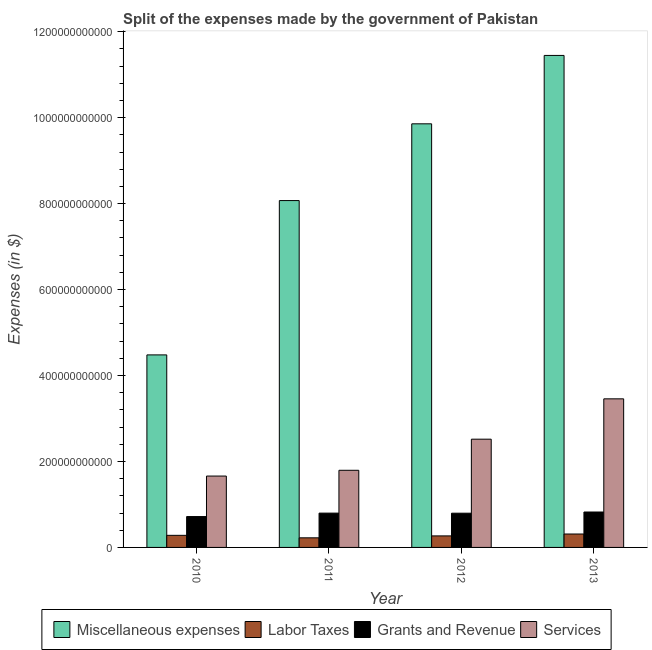How many groups of bars are there?
Give a very brief answer. 4. Are the number of bars per tick equal to the number of legend labels?
Your response must be concise. Yes. How many bars are there on the 1st tick from the left?
Ensure brevity in your answer.  4. What is the amount spent on miscellaneous expenses in 2012?
Give a very brief answer. 9.86e+11. Across all years, what is the maximum amount spent on labor taxes?
Give a very brief answer. 3.12e+1. Across all years, what is the minimum amount spent on grants and revenue?
Your answer should be compact. 7.18e+1. What is the total amount spent on grants and revenue in the graph?
Provide a succinct answer. 3.14e+11. What is the difference between the amount spent on services in 2010 and that in 2011?
Make the answer very short. -1.34e+1. What is the difference between the amount spent on labor taxes in 2013 and the amount spent on miscellaneous expenses in 2011?
Your answer should be compact. 8.87e+09. What is the average amount spent on miscellaneous expenses per year?
Your response must be concise. 8.46e+11. In the year 2013, what is the difference between the amount spent on labor taxes and amount spent on grants and revenue?
Make the answer very short. 0. What is the ratio of the amount spent on labor taxes in 2012 to that in 2013?
Keep it short and to the point. 0.86. Is the amount spent on grants and revenue in 2010 less than that in 2011?
Make the answer very short. Yes. What is the difference between the highest and the second highest amount spent on grants and revenue?
Offer a terse response. 2.57e+09. What is the difference between the highest and the lowest amount spent on labor taxes?
Give a very brief answer. 8.87e+09. Is it the case that in every year, the sum of the amount spent on services and amount spent on labor taxes is greater than the sum of amount spent on grants and revenue and amount spent on miscellaneous expenses?
Provide a succinct answer. No. What does the 3rd bar from the left in 2010 represents?
Your response must be concise. Grants and Revenue. What does the 2nd bar from the right in 2013 represents?
Provide a short and direct response. Grants and Revenue. Are all the bars in the graph horizontal?
Ensure brevity in your answer.  No. What is the difference between two consecutive major ticks on the Y-axis?
Make the answer very short. 2.00e+11. Does the graph contain any zero values?
Offer a very short reply. No. Does the graph contain grids?
Make the answer very short. No. How many legend labels are there?
Your response must be concise. 4. How are the legend labels stacked?
Your response must be concise. Horizontal. What is the title of the graph?
Your answer should be very brief. Split of the expenses made by the government of Pakistan. Does "UNPBF" appear as one of the legend labels in the graph?
Your answer should be very brief. No. What is the label or title of the X-axis?
Offer a terse response. Year. What is the label or title of the Y-axis?
Your answer should be very brief. Expenses (in $). What is the Expenses (in $) in Miscellaneous expenses in 2010?
Your answer should be very brief. 4.48e+11. What is the Expenses (in $) of Labor Taxes in 2010?
Your answer should be very brief. 2.81e+1. What is the Expenses (in $) of Grants and Revenue in 2010?
Keep it short and to the point. 7.18e+1. What is the Expenses (in $) of Services in 2010?
Offer a very short reply. 1.66e+11. What is the Expenses (in $) of Miscellaneous expenses in 2011?
Offer a terse response. 8.07e+11. What is the Expenses (in $) of Labor Taxes in 2011?
Your answer should be very brief. 2.23e+1. What is the Expenses (in $) in Grants and Revenue in 2011?
Your answer should be very brief. 7.98e+1. What is the Expenses (in $) of Services in 2011?
Give a very brief answer. 1.79e+11. What is the Expenses (in $) of Miscellaneous expenses in 2012?
Offer a very short reply. 9.86e+11. What is the Expenses (in $) in Labor Taxes in 2012?
Provide a short and direct response. 2.68e+1. What is the Expenses (in $) of Grants and Revenue in 2012?
Keep it short and to the point. 7.96e+1. What is the Expenses (in $) of Services in 2012?
Offer a terse response. 2.52e+11. What is the Expenses (in $) in Miscellaneous expenses in 2013?
Ensure brevity in your answer.  1.14e+12. What is the Expenses (in $) in Labor Taxes in 2013?
Offer a terse response. 3.12e+1. What is the Expenses (in $) in Grants and Revenue in 2013?
Ensure brevity in your answer.  8.24e+1. What is the Expenses (in $) in Services in 2013?
Offer a terse response. 3.46e+11. Across all years, what is the maximum Expenses (in $) of Miscellaneous expenses?
Keep it short and to the point. 1.14e+12. Across all years, what is the maximum Expenses (in $) of Labor Taxes?
Your response must be concise. 3.12e+1. Across all years, what is the maximum Expenses (in $) in Grants and Revenue?
Keep it short and to the point. 8.24e+1. Across all years, what is the maximum Expenses (in $) in Services?
Provide a succinct answer. 3.46e+11. Across all years, what is the minimum Expenses (in $) in Miscellaneous expenses?
Offer a very short reply. 4.48e+11. Across all years, what is the minimum Expenses (in $) in Labor Taxes?
Your answer should be compact. 2.23e+1. Across all years, what is the minimum Expenses (in $) in Grants and Revenue?
Keep it short and to the point. 7.18e+1. Across all years, what is the minimum Expenses (in $) of Services?
Give a very brief answer. 1.66e+11. What is the total Expenses (in $) in Miscellaneous expenses in the graph?
Your answer should be very brief. 3.39e+12. What is the total Expenses (in $) of Labor Taxes in the graph?
Ensure brevity in your answer.  1.08e+11. What is the total Expenses (in $) of Grants and Revenue in the graph?
Offer a terse response. 3.14e+11. What is the total Expenses (in $) of Services in the graph?
Offer a very short reply. 9.43e+11. What is the difference between the Expenses (in $) in Miscellaneous expenses in 2010 and that in 2011?
Give a very brief answer. -3.59e+11. What is the difference between the Expenses (in $) of Labor Taxes in 2010 and that in 2011?
Keep it short and to the point. 5.78e+09. What is the difference between the Expenses (in $) in Grants and Revenue in 2010 and that in 2011?
Keep it short and to the point. -8.00e+09. What is the difference between the Expenses (in $) of Services in 2010 and that in 2011?
Offer a terse response. -1.34e+1. What is the difference between the Expenses (in $) of Miscellaneous expenses in 2010 and that in 2012?
Make the answer very short. -5.38e+11. What is the difference between the Expenses (in $) of Labor Taxes in 2010 and that in 2012?
Provide a short and direct response. 1.30e+09. What is the difference between the Expenses (in $) of Grants and Revenue in 2010 and that in 2012?
Keep it short and to the point. -7.79e+09. What is the difference between the Expenses (in $) of Services in 2010 and that in 2012?
Your response must be concise. -8.58e+1. What is the difference between the Expenses (in $) in Miscellaneous expenses in 2010 and that in 2013?
Offer a terse response. -6.97e+11. What is the difference between the Expenses (in $) of Labor Taxes in 2010 and that in 2013?
Provide a short and direct response. -3.09e+09. What is the difference between the Expenses (in $) of Grants and Revenue in 2010 and that in 2013?
Offer a very short reply. -1.06e+1. What is the difference between the Expenses (in $) of Services in 2010 and that in 2013?
Offer a terse response. -1.80e+11. What is the difference between the Expenses (in $) in Miscellaneous expenses in 2011 and that in 2012?
Your response must be concise. -1.79e+11. What is the difference between the Expenses (in $) of Labor Taxes in 2011 and that in 2012?
Offer a terse response. -4.48e+09. What is the difference between the Expenses (in $) in Grants and Revenue in 2011 and that in 2012?
Ensure brevity in your answer.  2.04e+08. What is the difference between the Expenses (in $) of Services in 2011 and that in 2012?
Give a very brief answer. -7.24e+1. What is the difference between the Expenses (in $) of Miscellaneous expenses in 2011 and that in 2013?
Make the answer very short. -3.38e+11. What is the difference between the Expenses (in $) in Labor Taxes in 2011 and that in 2013?
Your response must be concise. -8.87e+09. What is the difference between the Expenses (in $) in Grants and Revenue in 2011 and that in 2013?
Your answer should be very brief. -2.57e+09. What is the difference between the Expenses (in $) in Services in 2011 and that in 2013?
Your answer should be very brief. -1.66e+11. What is the difference between the Expenses (in $) of Miscellaneous expenses in 2012 and that in 2013?
Offer a very short reply. -1.59e+11. What is the difference between the Expenses (in $) of Labor Taxes in 2012 and that in 2013?
Keep it short and to the point. -4.40e+09. What is the difference between the Expenses (in $) in Grants and Revenue in 2012 and that in 2013?
Provide a succinct answer. -2.78e+09. What is the difference between the Expenses (in $) in Services in 2012 and that in 2013?
Offer a very short reply. -9.39e+1. What is the difference between the Expenses (in $) of Miscellaneous expenses in 2010 and the Expenses (in $) of Labor Taxes in 2011?
Provide a short and direct response. 4.26e+11. What is the difference between the Expenses (in $) of Miscellaneous expenses in 2010 and the Expenses (in $) of Grants and Revenue in 2011?
Provide a short and direct response. 3.68e+11. What is the difference between the Expenses (in $) of Miscellaneous expenses in 2010 and the Expenses (in $) of Services in 2011?
Keep it short and to the point. 2.68e+11. What is the difference between the Expenses (in $) of Labor Taxes in 2010 and the Expenses (in $) of Grants and Revenue in 2011?
Ensure brevity in your answer.  -5.17e+1. What is the difference between the Expenses (in $) of Labor Taxes in 2010 and the Expenses (in $) of Services in 2011?
Your answer should be very brief. -1.51e+11. What is the difference between the Expenses (in $) of Grants and Revenue in 2010 and the Expenses (in $) of Services in 2011?
Ensure brevity in your answer.  -1.08e+11. What is the difference between the Expenses (in $) in Miscellaneous expenses in 2010 and the Expenses (in $) in Labor Taxes in 2012?
Make the answer very short. 4.21e+11. What is the difference between the Expenses (in $) of Miscellaneous expenses in 2010 and the Expenses (in $) of Grants and Revenue in 2012?
Provide a short and direct response. 3.68e+11. What is the difference between the Expenses (in $) in Miscellaneous expenses in 2010 and the Expenses (in $) in Services in 2012?
Provide a short and direct response. 1.96e+11. What is the difference between the Expenses (in $) of Labor Taxes in 2010 and the Expenses (in $) of Grants and Revenue in 2012?
Offer a terse response. -5.15e+1. What is the difference between the Expenses (in $) of Labor Taxes in 2010 and the Expenses (in $) of Services in 2012?
Make the answer very short. -2.24e+11. What is the difference between the Expenses (in $) of Grants and Revenue in 2010 and the Expenses (in $) of Services in 2012?
Make the answer very short. -1.80e+11. What is the difference between the Expenses (in $) of Miscellaneous expenses in 2010 and the Expenses (in $) of Labor Taxes in 2013?
Your answer should be very brief. 4.17e+11. What is the difference between the Expenses (in $) of Miscellaneous expenses in 2010 and the Expenses (in $) of Grants and Revenue in 2013?
Your response must be concise. 3.66e+11. What is the difference between the Expenses (in $) in Miscellaneous expenses in 2010 and the Expenses (in $) in Services in 2013?
Make the answer very short. 1.02e+11. What is the difference between the Expenses (in $) of Labor Taxes in 2010 and the Expenses (in $) of Grants and Revenue in 2013?
Provide a short and direct response. -5.43e+1. What is the difference between the Expenses (in $) in Labor Taxes in 2010 and the Expenses (in $) in Services in 2013?
Give a very brief answer. -3.18e+11. What is the difference between the Expenses (in $) in Grants and Revenue in 2010 and the Expenses (in $) in Services in 2013?
Provide a short and direct response. -2.74e+11. What is the difference between the Expenses (in $) in Miscellaneous expenses in 2011 and the Expenses (in $) in Labor Taxes in 2012?
Provide a short and direct response. 7.80e+11. What is the difference between the Expenses (in $) of Miscellaneous expenses in 2011 and the Expenses (in $) of Grants and Revenue in 2012?
Give a very brief answer. 7.27e+11. What is the difference between the Expenses (in $) in Miscellaneous expenses in 2011 and the Expenses (in $) in Services in 2012?
Your response must be concise. 5.55e+11. What is the difference between the Expenses (in $) in Labor Taxes in 2011 and the Expenses (in $) in Grants and Revenue in 2012?
Ensure brevity in your answer.  -5.73e+1. What is the difference between the Expenses (in $) of Labor Taxes in 2011 and the Expenses (in $) of Services in 2012?
Provide a short and direct response. -2.29e+11. What is the difference between the Expenses (in $) in Grants and Revenue in 2011 and the Expenses (in $) in Services in 2012?
Offer a very short reply. -1.72e+11. What is the difference between the Expenses (in $) in Miscellaneous expenses in 2011 and the Expenses (in $) in Labor Taxes in 2013?
Offer a terse response. 7.76e+11. What is the difference between the Expenses (in $) in Miscellaneous expenses in 2011 and the Expenses (in $) in Grants and Revenue in 2013?
Ensure brevity in your answer.  7.25e+11. What is the difference between the Expenses (in $) of Miscellaneous expenses in 2011 and the Expenses (in $) of Services in 2013?
Your response must be concise. 4.61e+11. What is the difference between the Expenses (in $) of Labor Taxes in 2011 and the Expenses (in $) of Grants and Revenue in 2013?
Provide a succinct answer. -6.01e+1. What is the difference between the Expenses (in $) of Labor Taxes in 2011 and the Expenses (in $) of Services in 2013?
Offer a terse response. -3.23e+11. What is the difference between the Expenses (in $) in Grants and Revenue in 2011 and the Expenses (in $) in Services in 2013?
Offer a terse response. -2.66e+11. What is the difference between the Expenses (in $) of Miscellaneous expenses in 2012 and the Expenses (in $) of Labor Taxes in 2013?
Your response must be concise. 9.54e+11. What is the difference between the Expenses (in $) of Miscellaneous expenses in 2012 and the Expenses (in $) of Grants and Revenue in 2013?
Offer a terse response. 9.03e+11. What is the difference between the Expenses (in $) in Miscellaneous expenses in 2012 and the Expenses (in $) in Services in 2013?
Provide a short and direct response. 6.40e+11. What is the difference between the Expenses (in $) in Labor Taxes in 2012 and the Expenses (in $) in Grants and Revenue in 2013?
Provide a succinct answer. -5.56e+1. What is the difference between the Expenses (in $) in Labor Taxes in 2012 and the Expenses (in $) in Services in 2013?
Offer a very short reply. -3.19e+11. What is the difference between the Expenses (in $) of Grants and Revenue in 2012 and the Expenses (in $) of Services in 2013?
Provide a succinct answer. -2.66e+11. What is the average Expenses (in $) in Miscellaneous expenses per year?
Your response must be concise. 8.46e+11. What is the average Expenses (in $) of Labor Taxes per year?
Make the answer very short. 2.71e+1. What is the average Expenses (in $) in Grants and Revenue per year?
Offer a terse response. 7.84e+1. What is the average Expenses (in $) in Services per year?
Ensure brevity in your answer.  2.36e+11. In the year 2010, what is the difference between the Expenses (in $) in Miscellaneous expenses and Expenses (in $) in Labor Taxes?
Your answer should be compact. 4.20e+11. In the year 2010, what is the difference between the Expenses (in $) in Miscellaneous expenses and Expenses (in $) in Grants and Revenue?
Your answer should be compact. 3.76e+11. In the year 2010, what is the difference between the Expenses (in $) in Miscellaneous expenses and Expenses (in $) in Services?
Your response must be concise. 2.82e+11. In the year 2010, what is the difference between the Expenses (in $) in Labor Taxes and Expenses (in $) in Grants and Revenue?
Your answer should be very brief. -4.37e+1. In the year 2010, what is the difference between the Expenses (in $) of Labor Taxes and Expenses (in $) of Services?
Keep it short and to the point. -1.38e+11. In the year 2010, what is the difference between the Expenses (in $) in Grants and Revenue and Expenses (in $) in Services?
Your response must be concise. -9.42e+1. In the year 2011, what is the difference between the Expenses (in $) in Miscellaneous expenses and Expenses (in $) in Labor Taxes?
Your response must be concise. 7.85e+11. In the year 2011, what is the difference between the Expenses (in $) in Miscellaneous expenses and Expenses (in $) in Grants and Revenue?
Give a very brief answer. 7.27e+11. In the year 2011, what is the difference between the Expenses (in $) of Miscellaneous expenses and Expenses (in $) of Services?
Your answer should be compact. 6.28e+11. In the year 2011, what is the difference between the Expenses (in $) of Labor Taxes and Expenses (in $) of Grants and Revenue?
Provide a succinct answer. -5.75e+1. In the year 2011, what is the difference between the Expenses (in $) in Labor Taxes and Expenses (in $) in Services?
Your answer should be very brief. -1.57e+11. In the year 2011, what is the difference between the Expenses (in $) in Grants and Revenue and Expenses (in $) in Services?
Keep it short and to the point. -9.96e+1. In the year 2012, what is the difference between the Expenses (in $) of Miscellaneous expenses and Expenses (in $) of Labor Taxes?
Your answer should be compact. 9.59e+11. In the year 2012, what is the difference between the Expenses (in $) of Miscellaneous expenses and Expenses (in $) of Grants and Revenue?
Make the answer very short. 9.06e+11. In the year 2012, what is the difference between the Expenses (in $) in Miscellaneous expenses and Expenses (in $) in Services?
Give a very brief answer. 7.34e+11. In the year 2012, what is the difference between the Expenses (in $) in Labor Taxes and Expenses (in $) in Grants and Revenue?
Your answer should be compact. -5.28e+1. In the year 2012, what is the difference between the Expenses (in $) in Labor Taxes and Expenses (in $) in Services?
Offer a very short reply. -2.25e+11. In the year 2012, what is the difference between the Expenses (in $) in Grants and Revenue and Expenses (in $) in Services?
Provide a short and direct response. -1.72e+11. In the year 2013, what is the difference between the Expenses (in $) of Miscellaneous expenses and Expenses (in $) of Labor Taxes?
Keep it short and to the point. 1.11e+12. In the year 2013, what is the difference between the Expenses (in $) in Miscellaneous expenses and Expenses (in $) in Grants and Revenue?
Make the answer very short. 1.06e+12. In the year 2013, what is the difference between the Expenses (in $) of Miscellaneous expenses and Expenses (in $) of Services?
Your response must be concise. 7.99e+11. In the year 2013, what is the difference between the Expenses (in $) in Labor Taxes and Expenses (in $) in Grants and Revenue?
Offer a terse response. -5.12e+1. In the year 2013, what is the difference between the Expenses (in $) of Labor Taxes and Expenses (in $) of Services?
Offer a terse response. -3.15e+11. In the year 2013, what is the difference between the Expenses (in $) in Grants and Revenue and Expenses (in $) in Services?
Your answer should be compact. -2.63e+11. What is the ratio of the Expenses (in $) in Miscellaneous expenses in 2010 to that in 2011?
Offer a terse response. 0.56. What is the ratio of the Expenses (in $) in Labor Taxes in 2010 to that in 2011?
Keep it short and to the point. 1.26. What is the ratio of the Expenses (in $) of Grants and Revenue in 2010 to that in 2011?
Keep it short and to the point. 0.9. What is the ratio of the Expenses (in $) of Services in 2010 to that in 2011?
Provide a short and direct response. 0.93. What is the ratio of the Expenses (in $) in Miscellaneous expenses in 2010 to that in 2012?
Make the answer very short. 0.45. What is the ratio of the Expenses (in $) of Labor Taxes in 2010 to that in 2012?
Offer a very short reply. 1.05. What is the ratio of the Expenses (in $) in Grants and Revenue in 2010 to that in 2012?
Offer a very short reply. 0.9. What is the ratio of the Expenses (in $) in Services in 2010 to that in 2012?
Keep it short and to the point. 0.66. What is the ratio of the Expenses (in $) of Miscellaneous expenses in 2010 to that in 2013?
Your response must be concise. 0.39. What is the ratio of the Expenses (in $) in Labor Taxes in 2010 to that in 2013?
Your answer should be very brief. 0.9. What is the ratio of the Expenses (in $) of Grants and Revenue in 2010 to that in 2013?
Your answer should be compact. 0.87. What is the ratio of the Expenses (in $) in Services in 2010 to that in 2013?
Make the answer very short. 0.48. What is the ratio of the Expenses (in $) in Miscellaneous expenses in 2011 to that in 2012?
Offer a terse response. 0.82. What is the ratio of the Expenses (in $) of Labor Taxes in 2011 to that in 2012?
Make the answer very short. 0.83. What is the ratio of the Expenses (in $) of Grants and Revenue in 2011 to that in 2012?
Your response must be concise. 1. What is the ratio of the Expenses (in $) in Services in 2011 to that in 2012?
Your answer should be compact. 0.71. What is the ratio of the Expenses (in $) in Miscellaneous expenses in 2011 to that in 2013?
Ensure brevity in your answer.  0.7. What is the ratio of the Expenses (in $) in Labor Taxes in 2011 to that in 2013?
Offer a very short reply. 0.72. What is the ratio of the Expenses (in $) of Grants and Revenue in 2011 to that in 2013?
Offer a terse response. 0.97. What is the ratio of the Expenses (in $) in Services in 2011 to that in 2013?
Provide a short and direct response. 0.52. What is the ratio of the Expenses (in $) in Miscellaneous expenses in 2012 to that in 2013?
Make the answer very short. 0.86. What is the ratio of the Expenses (in $) of Labor Taxes in 2012 to that in 2013?
Your answer should be very brief. 0.86. What is the ratio of the Expenses (in $) of Grants and Revenue in 2012 to that in 2013?
Your response must be concise. 0.97. What is the ratio of the Expenses (in $) in Services in 2012 to that in 2013?
Ensure brevity in your answer.  0.73. What is the difference between the highest and the second highest Expenses (in $) of Miscellaneous expenses?
Your answer should be compact. 1.59e+11. What is the difference between the highest and the second highest Expenses (in $) of Labor Taxes?
Your answer should be very brief. 3.09e+09. What is the difference between the highest and the second highest Expenses (in $) of Grants and Revenue?
Ensure brevity in your answer.  2.57e+09. What is the difference between the highest and the second highest Expenses (in $) in Services?
Provide a succinct answer. 9.39e+1. What is the difference between the highest and the lowest Expenses (in $) in Miscellaneous expenses?
Your answer should be compact. 6.97e+11. What is the difference between the highest and the lowest Expenses (in $) in Labor Taxes?
Your answer should be compact. 8.87e+09. What is the difference between the highest and the lowest Expenses (in $) of Grants and Revenue?
Provide a short and direct response. 1.06e+1. What is the difference between the highest and the lowest Expenses (in $) in Services?
Provide a succinct answer. 1.80e+11. 